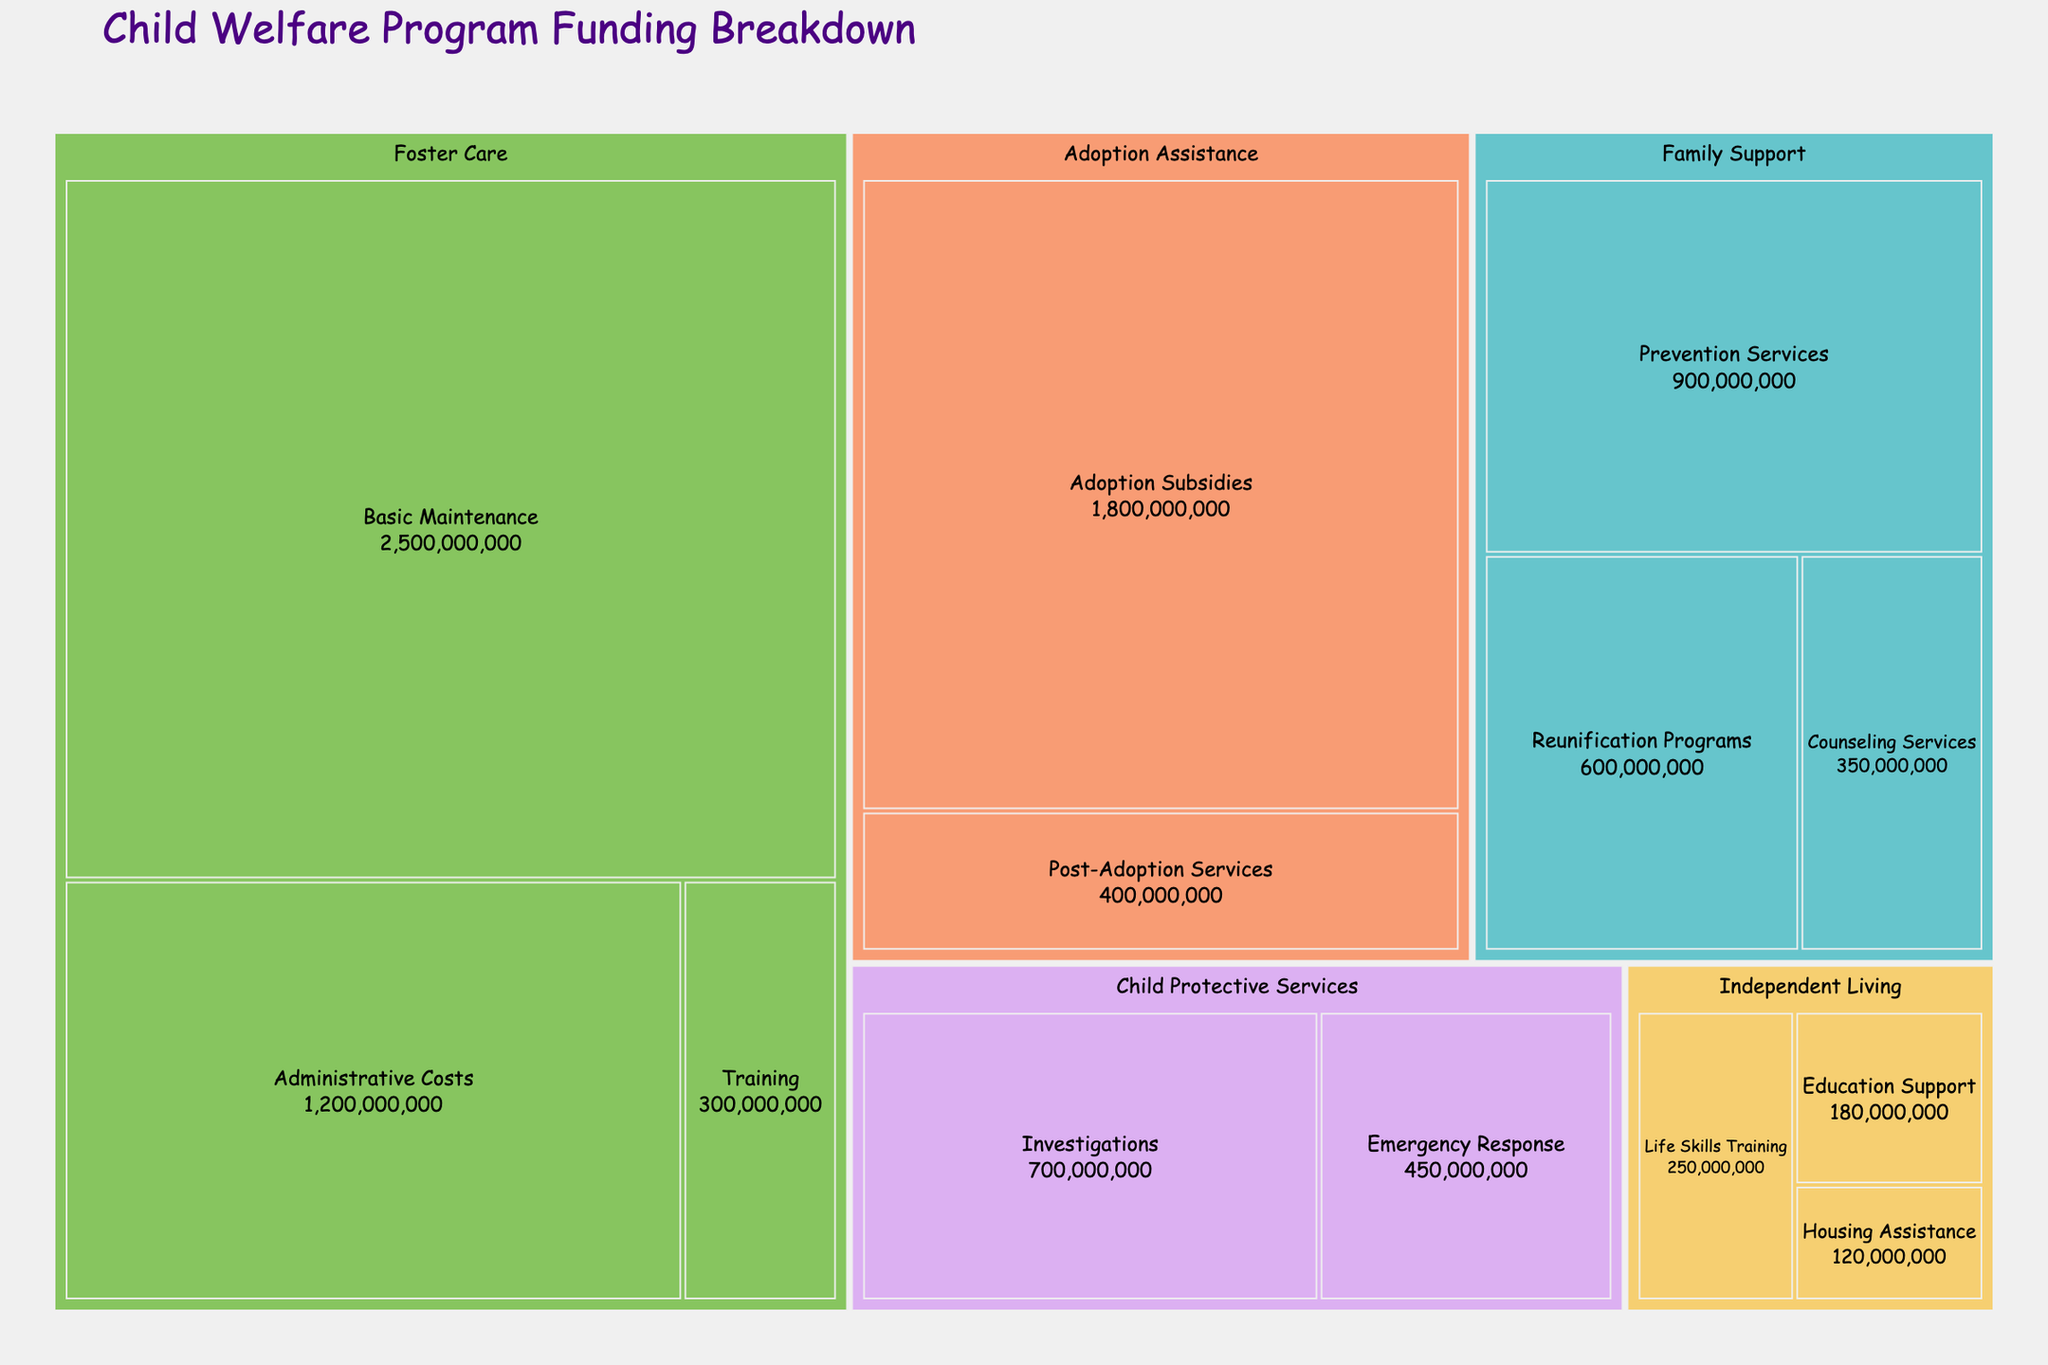What is the title of the figure? The title of the figure is shown at the top in larger font size. It reads "Child Welfare Program Funding Breakdown".
Answer: Child Welfare Program Funding Breakdown What category received the most funding? By looking at the colored rectangles in the treemap, the largest area indicates the category with the most funding, which is "Foster Care".
Answer: Foster Care What is the total funding for Family Support Services? Sum up the amounts from all subcategories under Family Support: Prevention Services ($900,000,000), Reunification Programs ($600,000,000), and Counseling Services ($350,000,000). The total is $900,000,000 + $600,000,000 + $350,000,000 = $1,850,000,000.
Answer: $1,850,000,000 Which subcategory under Foster Care has the highest allocation? Within the Foster Care category, the largest rectangle represents the subcategory with the highest allocation, which is "Basic Maintenance" with $2,500,000,000.
Answer: Basic Maintenance How does the funding for Adoption Assistance compare to Child Protective Services? Summing up all subcategories under each category, Adoption Assistance is $1,800,000,000 (Adoption Subsidies) + $400,000,000 (Post-Adoption Services) = $2,200,000,000. For Child Protective Services, it is $700,000,000 (Investigations) + $450,000,000 (Emergency Response) = $1,150,000,000. Comparing these totals, Adoption Assistance received more funding.
Answer: Adoption Assistance > Child Protective Services What is the combined funding for Independent Living services? Sum the amounts for all subcategories under Independent Living: Life Skills Training ($250,000,000), Education Support ($180,000,000), and Housing Assistance ($120,000,000). Thus, $250,000,000 + $180,000,000 + $120,000,000 = $550,000,000.
Answer: $550,000,000 What percentage of the total funding does Basic Maintenance account for? First, find the total funding of all categories and subcategories, then calculate the percentage. Total funding is $9,050,000,000. Basic Maintenance is $2,500,000,000. The percentage is ($2,500,000,000 / $9,050,000,000) * 100 ≈ 27.62%.
Answer: 27.62% Which subcategory within Family Support has the smallest allocation? Within the Family Support category, the smallest rectangle represents the subcategory with the smallest allocation, which is "Counseling Services" with $350,000,000.
Answer: Counseling Services How much more funding does Foster Care receive compared to Independent Living? Total funding for Foster Care is $2,500,000,000 (Basic Maintenance) + $1,200,000,000 (Administrative Costs) + $300,000,000 (Training) = $4,000,000,000. For Independent Living, it is $250,000,000 (Life Skills Training) + $180,000,000 (Education Support) + $120,000,000 (Housing Assistance) = $550,000,000. The difference is $4,000,000,000 - $550,000,000 = $3,450,000,000.
Answer: $3,450,000,000 